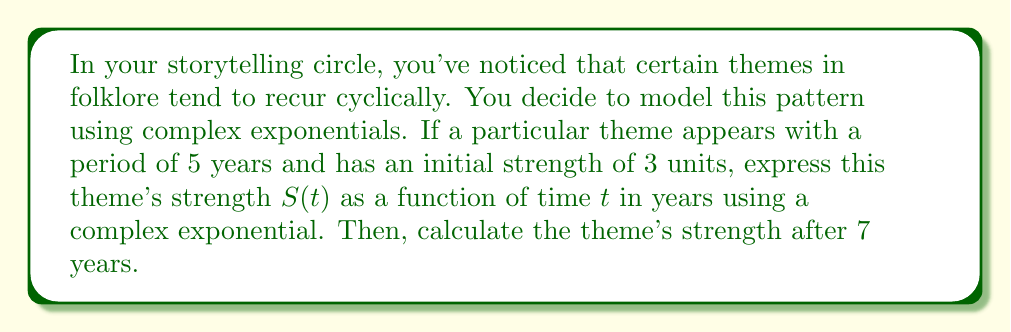Help me with this question. Let's approach this step-by-step:

1) The general form of a complex exponential for cyclical phenomena is:

   $$S(t) = Ae^{i\omega t}$$

   where $A$ is the amplitude (initial strength) and $\omega$ is the angular frequency.

2) We're given that the initial strength $A = 3$.

3) To find $\omega$, we use the relationship between period $T$ and angular frequency:

   $$\omega = \frac{2\pi}{T}$$

   Here, $T = 5$ years, so:

   $$\omega = \frac{2\pi}{5}$$

4) Substituting these into our general form:

   $$S(t) = 3e^{i\frac{2\pi}{5}t}$$

5) To find the strength after 7 years, we evaluate $S(7)$:

   $$S(7) = 3e^{i\frac{2\pi}{5}(7)}$$

6) Simplify the exponent:

   $$S(7) = 3e^{i\frac{14\pi}{5}}$$

7) Recall Euler's formula: $e^{ix} = \cos x + i\sin x$

   $$S(7) = 3(\cos(\frac{14\pi}{5}) + i\sin(\frac{14\pi}{5}))$$

8) Evaluate:

   $$S(7) = 3(\cos(2.8\pi) + i\sin(2.8\pi))$$
   $$S(7) \approx 3(0.309 - i0.951)$$
   $$S(7) \approx 0.927 - i2.853$$

The strength after 7 years is represented by this complex number.
Answer: $S(t) = 3e^{i\frac{2\pi}{5}t}$

$S(7) \approx 0.927 - i2.853$ 